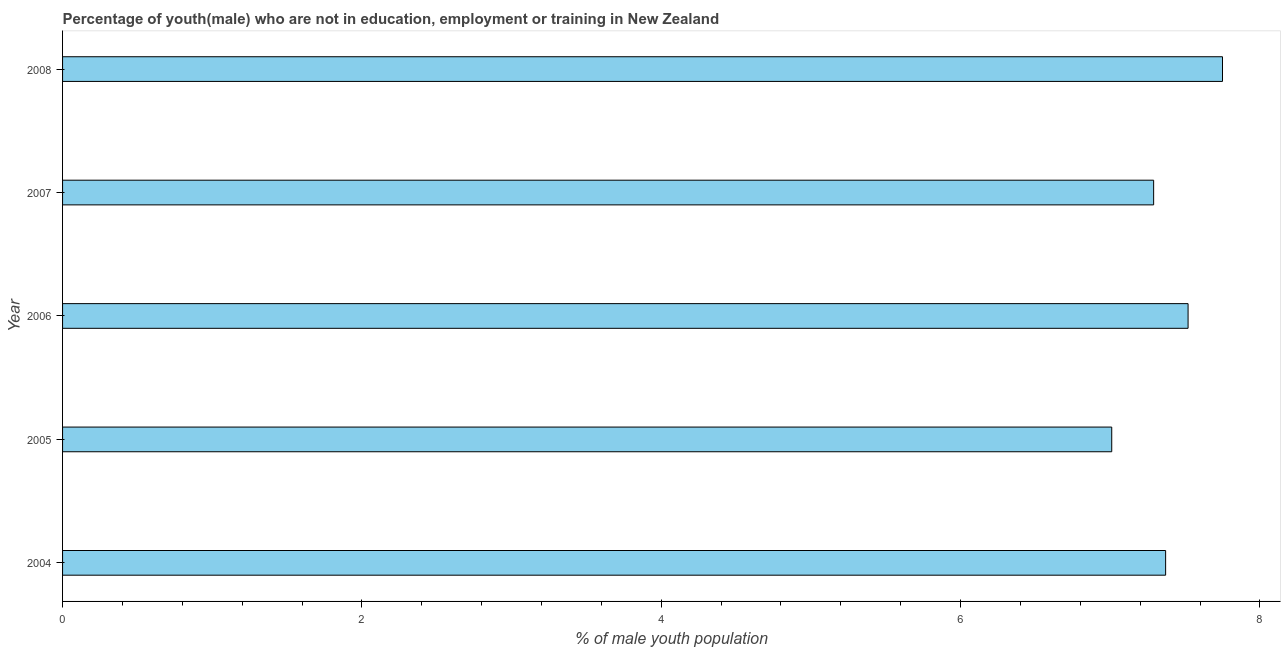Does the graph contain grids?
Your answer should be very brief. No. What is the title of the graph?
Give a very brief answer. Percentage of youth(male) who are not in education, employment or training in New Zealand. What is the label or title of the X-axis?
Make the answer very short. % of male youth population. What is the unemployed male youth population in 2005?
Keep it short and to the point. 7.01. Across all years, what is the maximum unemployed male youth population?
Offer a very short reply. 7.75. Across all years, what is the minimum unemployed male youth population?
Provide a short and direct response. 7.01. In which year was the unemployed male youth population minimum?
Give a very brief answer. 2005. What is the sum of the unemployed male youth population?
Make the answer very short. 36.94. What is the difference between the unemployed male youth population in 2004 and 2008?
Provide a succinct answer. -0.38. What is the average unemployed male youth population per year?
Provide a succinct answer. 7.39. What is the median unemployed male youth population?
Your answer should be compact. 7.37. Do a majority of the years between 2006 and 2005 (inclusive) have unemployed male youth population greater than 5.6 %?
Provide a short and direct response. No. What is the ratio of the unemployed male youth population in 2007 to that in 2008?
Your response must be concise. 0.94. Is the unemployed male youth population in 2006 less than that in 2008?
Your response must be concise. Yes. Is the difference between the unemployed male youth population in 2005 and 2008 greater than the difference between any two years?
Provide a succinct answer. Yes. What is the difference between the highest and the second highest unemployed male youth population?
Keep it short and to the point. 0.23. What is the difference between the highest and the lowest unemployed male youth population?
Ensure brevity in your answer.  0.74. In how many years, is the unemployed male youth population greater than the average unemployed male youth population taken over all years?
Keep it short and to the point. 2. How many bars are there?
Make the answer very short. 5. What is the difference between two consecutive major ticks on the X-axis?
Your response must be concise. 2. What is the % of male youth population in 2004?
Provide a succinct answer. 7.37. What is the % of male youth population of 2005?
Offer a very short reply. 7.01. What is the % of male youth population in 2006?
Provide a short and direct response. 7.52. What is the % of male youth population in 2007?
Offer a very short reply. 7.29. What is the % of male youth population of 2008?
Provide a short and direct response. 7.75. What is the difference between the % of male youth population in 2004 and 2005?
Your answer should be very brief. 0.36. What is the difference between the % of male youth population in 2004 and 2006?
Your response must be concise. -0.15. What is the difference between the % of male youth population in 2004 and 2007?
Ensure brevity in your answer.  0.08. What is the difference between the % of male youth population in 2004 and 2008?
Your answer should be compact. -0.38. What is the difference between the % of male youth population in 2005 and 2006?
Keep it short and to the point. -0.51. What is the difference between the % of male youth population in 2005 and 2007?
Ensure brevity in your answer.  -0.28. What is the difference between the % of male youth population in 2005 and 2008?
Keep it short and to the point. -0.74. What is the difference between the % of male youth population in 2006 and 2007?
Your answer should be compact. 0.23. What is the difference between the % of male youth population in 2006 and 2008?
Give a very brief answer. -0.23. What is the difference between the % of male youth population in 2007 and 2008?
Keep it short and to the point. -0.46. What is the ratio of the % of male youth population in 2004 to that in 2005?
Give a very brief answer. 1.05. What is the ratio of the % of male youth population in 2004 to that in 2007?
Provide a succinct answer. 1.01. What is the ratio of the % of male youth population in 2004 to that in 2008?
Provide a succinct answer. 0.95. What is the ratio of the % of male youth population in 2005 to that in 2006?
Offer a terse response. 0.93. What is the ratio of the % of male youth population in 2005 to that in 2007?
Your response must be concise. 0.96. What is the ratio of the % of male youth population in 2005 to that in 2008?
Provide a succinct answer. 0.91. What is the ratio of the % of male youth population in 2006 to that in 2007?
Your response must be concise. 1.03. What is the ratio of the % of male youth population in 2007 to that in 2008?
Provide a succinct answer. 0.94. 